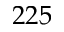<formula> <loc_0><loc_0><loc_500><loc_500>2 2 5</formula> 